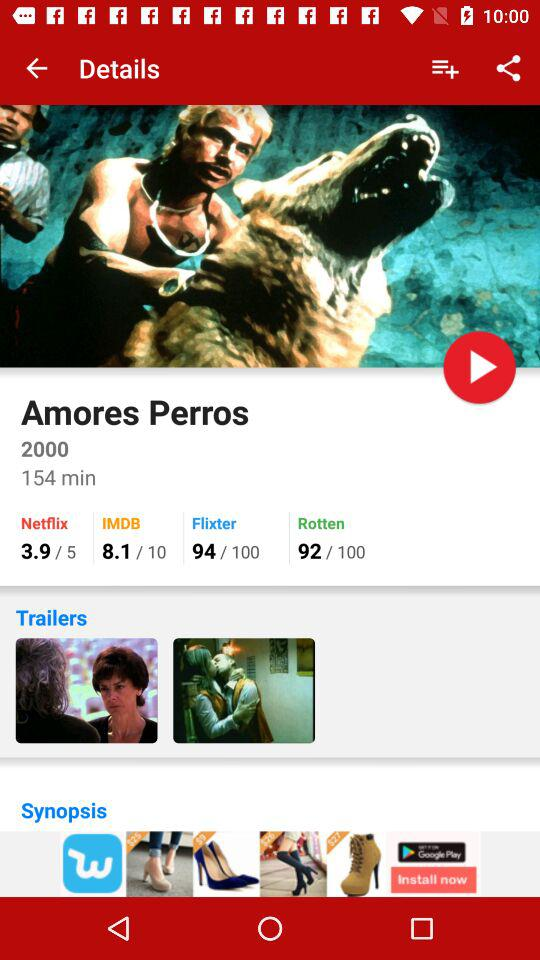What is the rating of Amores Perros on Netflix? The rating is 3.9. 